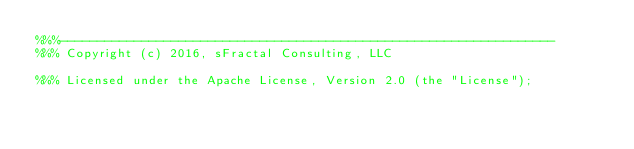Convert code to text. <code><loc_0><loc_0><loc_500><loc_500><_Erlang_>%%%-------------------------------------------------------------------
%%% Copyright (c) 2016, sFractal Consulting, LLC

%%% Licensed under the Apache License, Version 2.0 (the "License");</code> 